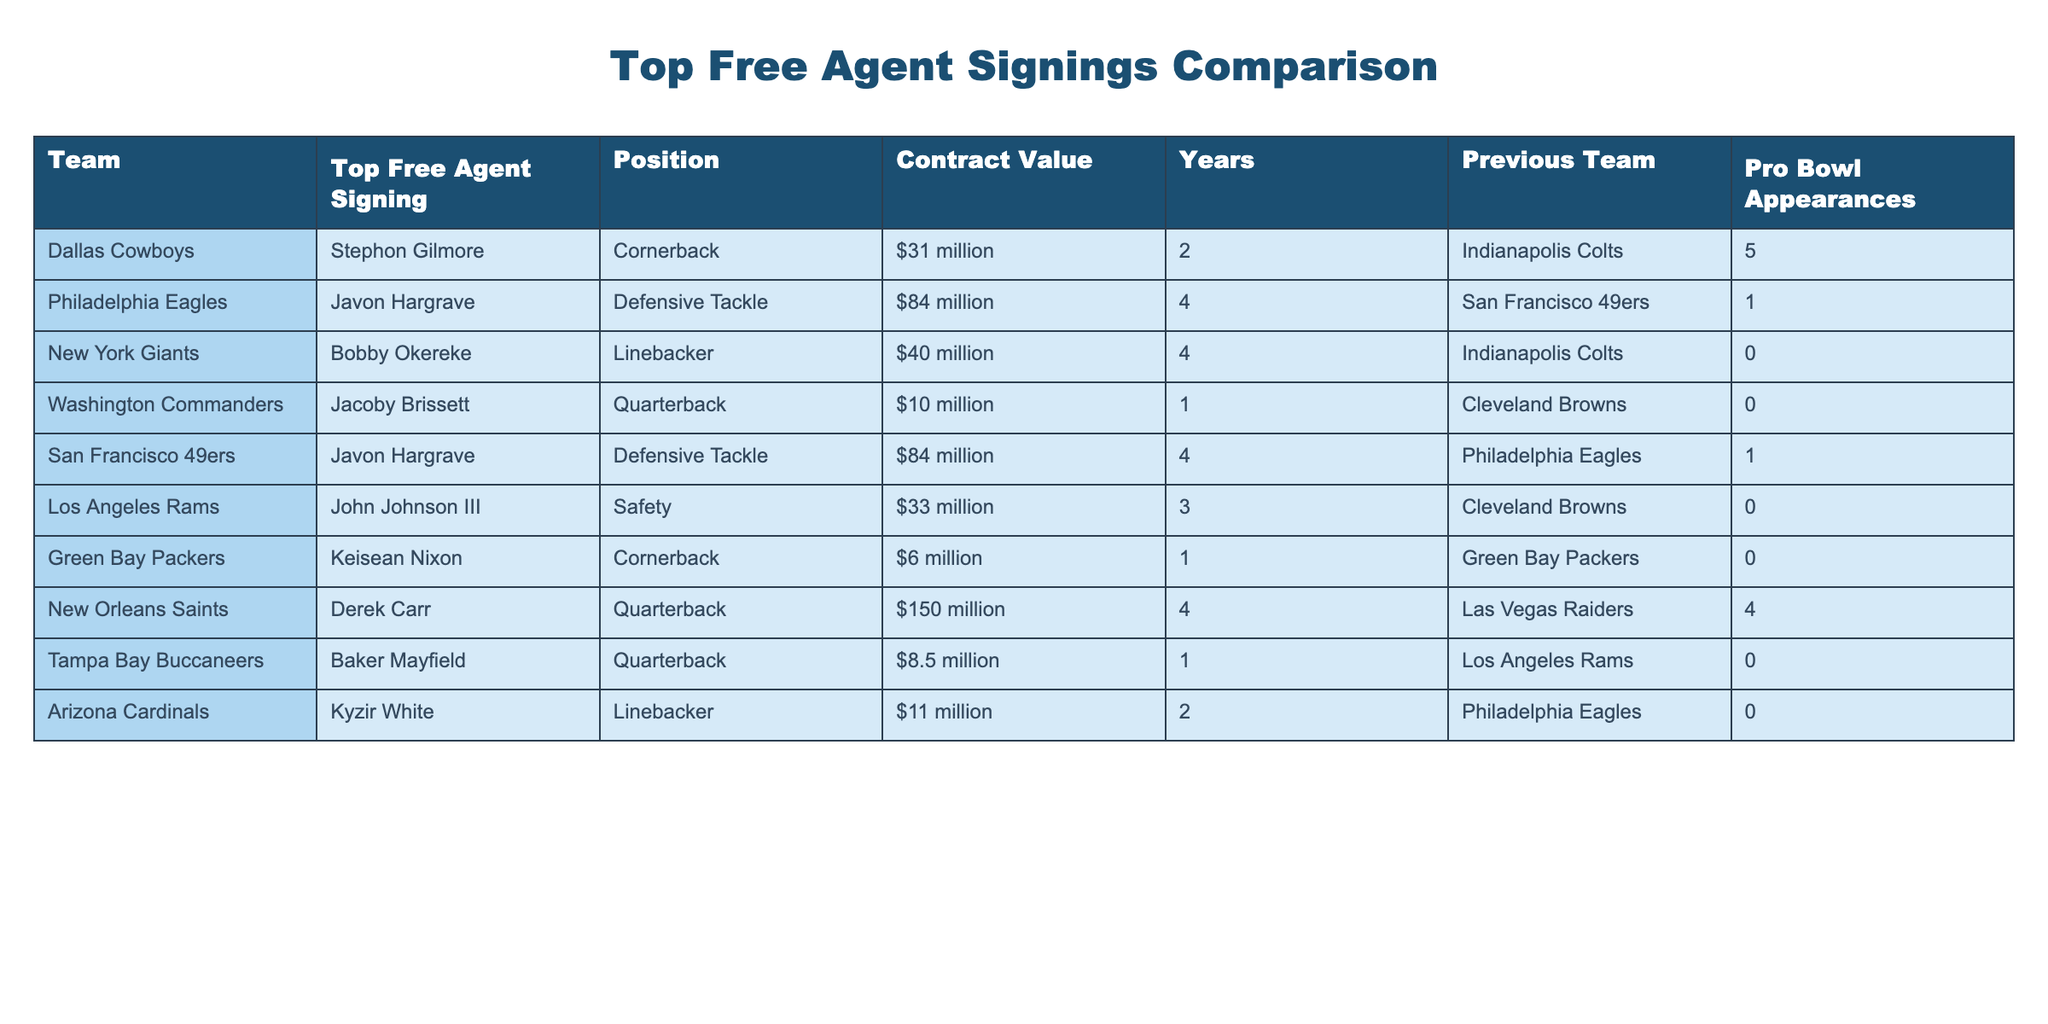What is the contract value of Stephon Gilmore? The table indicates that the contract value of Stephon Gilmore, who is the top free agent signing for the Dallas Cowboys, is listed as $31 million.
Answer: $31 million Which player has the highest contract value? The table shows that the player with the highest contract value is Derek Carr of the New Orleans Saints, with a contract worth $150 million.
Answer: $150 million How many Pro Bowl appearances does Jacoby Brissett have? According to the table, Jacoby Brissett, the quarterback for the Washington Commanders, has 0 Pro Bowl appearances.
Answer: 0 Pro Bowl appearances Which team's top free agent signing is a Defensive Tackle? By reviewing the table, it notes that both the Philadelphia Eagles and San Francisco 49ers signed Javon Hargrave as a Defensive Tackle, with a contract value of $84 million for both teams.
Answer: Philadelphia Eagles and San Francisco 49ers What is the average contract value of the players listed for all teams? To find the average, we first total the contract values: $31 million + $84 million + $40 million + $10 million + $84 million + $33 million + $6 million + $150 million + $8.5 million + $11 million = $417.5 million. There are 10 players, so the average contract value is $417.5 million / 10 = $41.75 million.
Answer: $41.75 million Did any team sign a quarterback for more than $100 million? The table presents Derek Carr of the New Orleans Saints, who signed a contract worth $150 million, confirming that yes, there is a quarterback with a contract exceeding $100 million.
Answer: Yes What is the total number of Pro Bowl appearances for all players listed? Adding the Pro Bowl appearances from the table: 5 (Gilmore) + 1 (Hargrave) + 0 (Okereke) + 0 (Brissett) + 1 (Hargrave) + 0 (Johnson III) + 0 (Nixon) + 4 (Carr) + 0 (Mayfield) + 0 (White) = 11 Pro Bowl appearances total.
Answer: 11 Pro Bowl appearances Which player has more than 4 Pro Bowl appearances? Upon examining the table, only Stephon Gilmore has more than 4 Pro Bowl appearances, specifically 5.
Answer: Stephon Gilmore What is the difference in contract value between the highest and lowest signing? The highest contract value is $150 million (Derek Carr), and the lowest is $6 million (Keisean Nixon). The difference is $150 million - $6 million = $144 million.
Answer: $144 million 